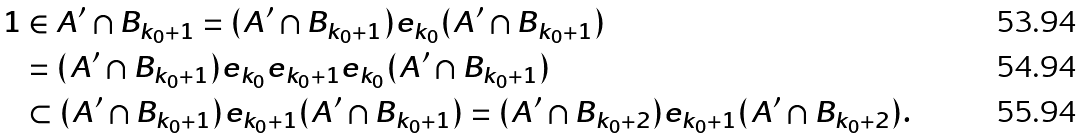<formula> <loc_0><loc_0><loc_500><loc_500>1 & \in A ^ { \prime } \cap B _ { k _ { 0 } + 1 } = ( A ^ { \prime } \cap B _ { k _ { 0 } + 1 } ) e _ { k _ { 0 } } ( A ^ { \prime } \cap B _ { k _ { 0 } + 1 } ) \\ & = ( A ^ { \prime } \cap B _ { k _ { 0 } + 1 } ) e _ { k _ { 0 } } e _ { k _ { 0 } + 1 } e _ { k _ { 0 } } ( A ^ { \prime } \cap B _ { k _ { 0 } + 1 } ) \\ & \subset ( A ^ { \prime } \cap B _ { k _ { 0 } + 1 } ) e _ { k _ { 0 } + 1 } ( A ^ { \prime } \cap B _ { k _ { 0 } + 1 } ) = ( A ^ { \prime } \cap B _ { k _ { 0 } + 2 } ) e _ { k _ { 0 } + 1 } ( A ^ { \prime } \cap B _ { k _ { 0 } + 2 } ) .</formula> 